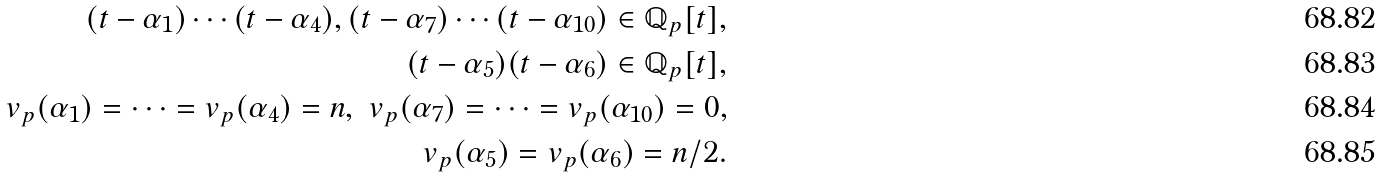Convert formula to latex. <formula><loc_0><loc_0><loc_500><loc_500>( t - \alpha _ { 1 } ) \cdots ( t - \alpha _ { 4 } ) , ( t - \alpha _ { 7 } ) \cdots ( t - \alpha _ { 1 0 } ) \in \mathbb { Q } _ { p } [ t ] , \\ ( t - \alpha _ { 5 } ) ( t - \alpha _ { 6 } ) \in \mathbb { Q } _ { p } [ t ] , \\ v _ { p } ( \alpha _ { 1 } ) = \cdots = v _ { p } ( \alpha _ { 4 } ) = n , \ v _ { p } ( \alpha _ { 7 } ) = \cdots = v _ { p } ( \alpha _ { 1 0 } ) = 0 , \\ v _ { p } ( \alpha _ { 5 } ) = v _ { p } ( \alpha _ { 6 } ) = n / 2 .</formula> 